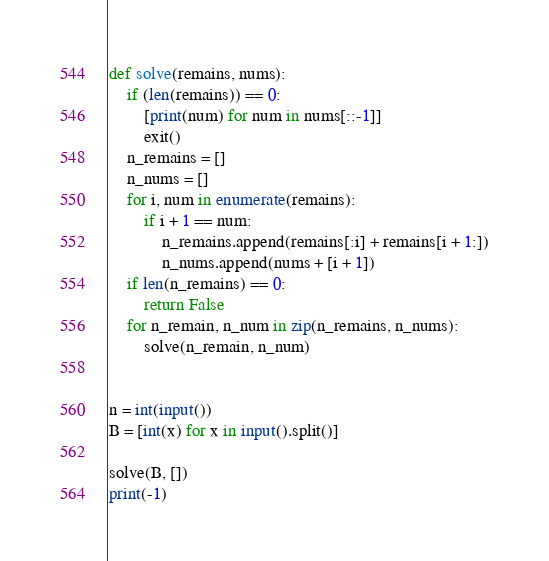Convert code to text. <code><loc_0><loc_0><loc_500><loc_500><_Python_>def solve(remains, nums):
    if (len(remains)) == 0:
        [print(num) for num in nums[::-1]]
        exit()
    n_remains = []
    n_nums = []
    for i, num in enumerate(remains):
        if i + 1 == num:
            n_remains.append(remains[:i] + remains[i + 1:])
            n_nums.append(nums + [i + 1])
    if len(n_remains) == 0:
        return False
    for n_remain, n_num in zip(n_remains, n_nums):
        solve(n_remain, n_num)


n = int(input())
B = [int(x) for x in input().split()]

solve(B, [])
print(-1)
</code> 